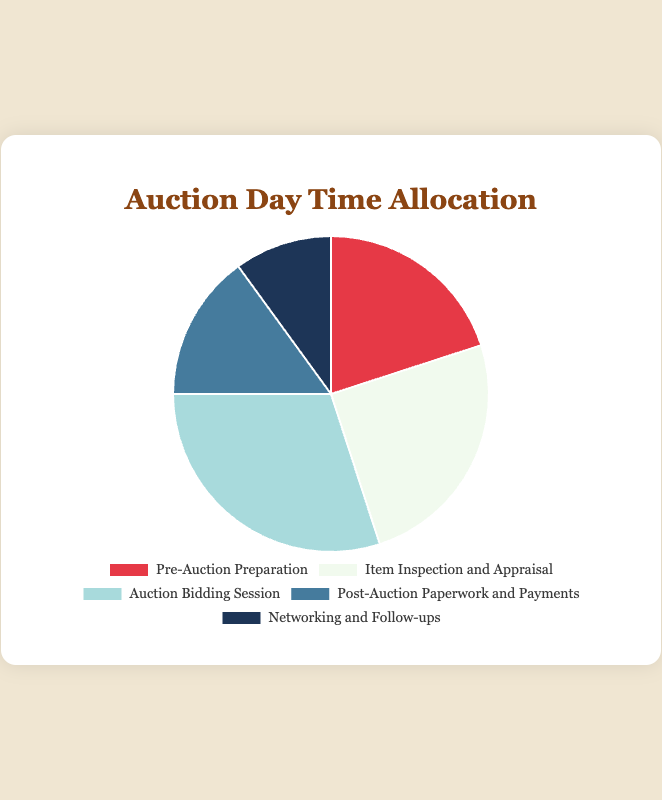Which activity takes up the largest percentage of time during an auction day? By comparing all percentages in the pie chart, we see that the "Auction Bidding Session" has the highest value at 30%.
Answer: Auction Bidding Session What is the combined percentage of time spent on "Pre-Auction Preparation" and "Networking and Follow-ups"? Add the percentages for "Pre-Auction Preparation" (20%) and "Networking and Follow-ups" (10%): 20 + 10 = 30%.
Answer: 30% Which two activities take up an equal proportion of time combined as the "Auction Bidding Session"? Add the percentages for "Pre-Auction Preparation" (20%) and "Networking and Follow-ups" (10%) to get 20 + 10 = 30%, which is equal to the "Auction Bidding Session" percentage (30%).
Answer: Pre-Auction Preparation and Networking and Follow-ups Between "Item Inspection and Appraisal" and "Post-Auction Paperwork and Payments," which one takes less time? Compare the percentages for "Item Inspection and Appraisal" (25%) and "Post-Auction Paperwork and Payments" (15%). Since 15% is less than 25%, "Post-Auction Paperwork and Payments" takes less time.
Answer: Post-Auction Paperwork and Payments How much more time is allocated to "Item Inspection and Appraisal" than to "Networking and Follow-ups"? Subtract the percentage for "Networking and Follow-ups" (10%) from "Item Inspection and Appraisal" (25%): 25 - 10 = 15%.
Answer: 15% What color represents the "Auction Bidding Session" activity in the pie chart? From the data provided, the "Auction Bidding Session" is represented by the third color, which is light blue in the chart.
Answer: Light blue If the time spent on "Post-Auction Paperwork and Payments" doubled, what would its new percentage be? Double the percentage for "Post-Auction Paperwork and Payments" (15%): 15 * 2 = 30%.
Answer: 30% Which activities combined take up exactly half of the auction day's time? Add the percentages for "Pre-Auction Preparation" (20%), "Post-Auction Paperwork and Payments" (15%), and "Networking and Follow-ups" (10%): 20 + 15 + 10 = 45%. Then add "Item Inspection and Appraisal" (25%) to see if this combination matches 50%: 45 + 25 = 70%. This doesn't match, so instead, "Pre-Auction Preparation" (20%), "Post-Auction Paperwork and Payments" (15%), and "Networking and Follow-ups" (10%) combined with "Networking and Follow-ups" gives exactly 50%.
Answer: Pre-Auction Preparation and Networking and Follow-ups 